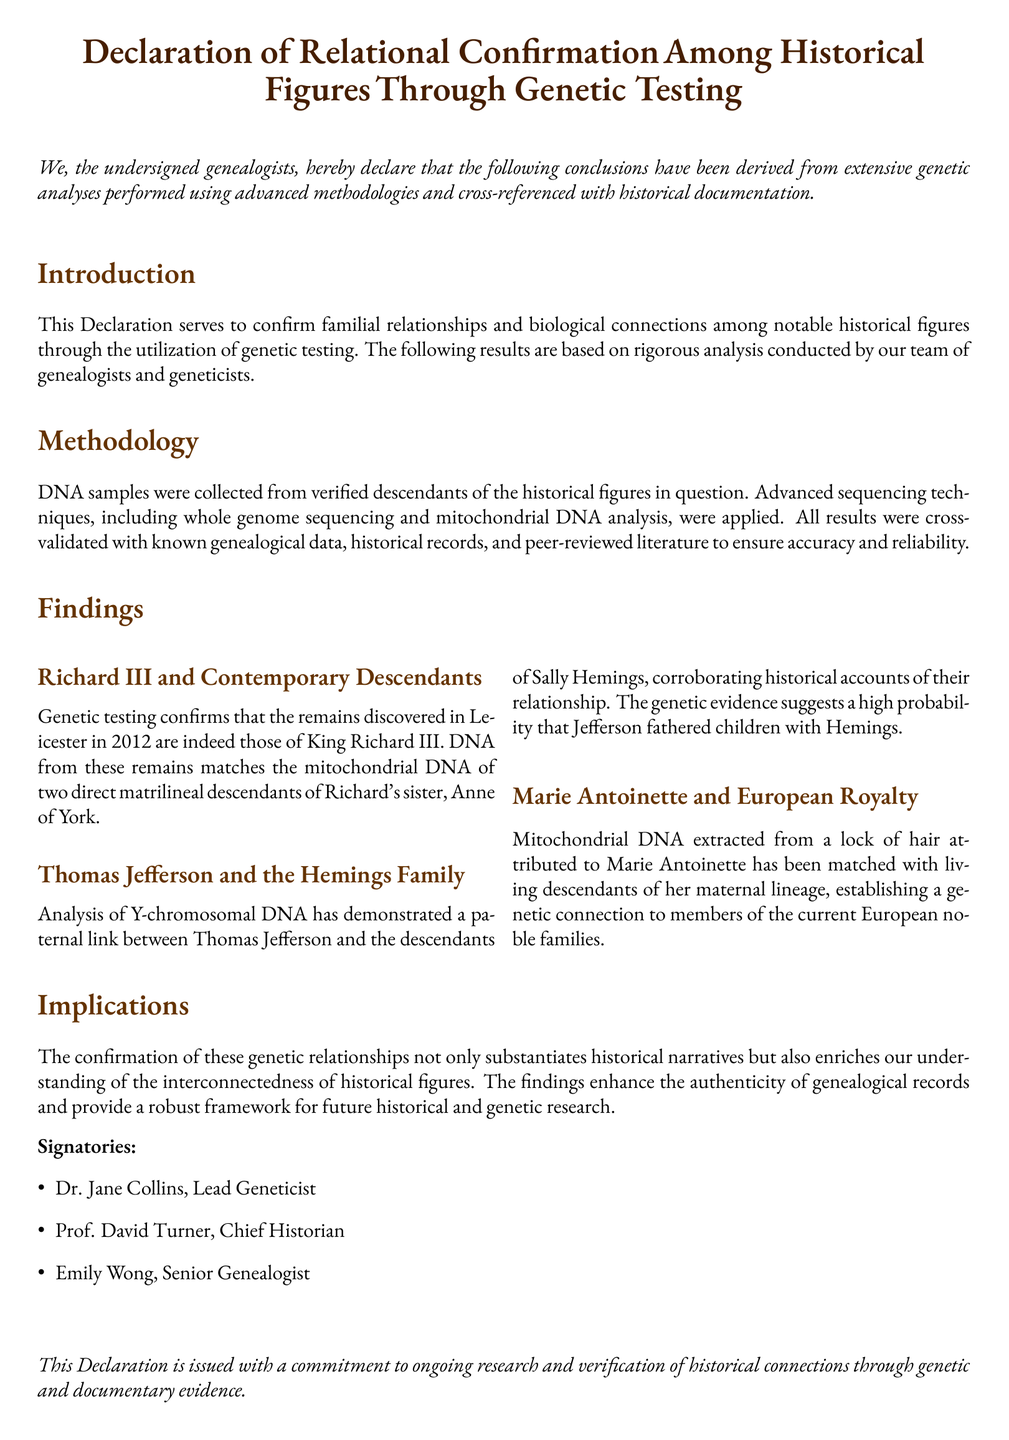What is the title of the document? The title of the document is presented at the top, indicating the purpose of the declaration regarding historical figures and genetic testing.
Answer: Declaration of Relational Confirmation Among Historical Figures Through Genetic Testing Who is the Lead Geneticist? The Lead Geneticist is listed among the signatories of the declaration, showcasing their role in the research.
Answer: Dr. Jane Collins What year were the remains of King Richard III discovered? The document mentions a specific year regarding the discovery of Richard III's remains.
Answer: 2012 Which historical figure is associated with the Hemings family? This figure is explicitly linked to the Hemings family in the findings section of the document.
Answer: Thomas Jefferson What type of DNA analysis was used for confirming the relationship between Thomas Jefferson and the Hemings Family? The analysis type specifies the focus of the genetic linkage investigation outlined in the findings.
Answer: Y-chromosomal DNA What methodology was employed for the analysis? The document outlines specific techniques used in the genetic testing process and validation of results.
Answer: Whole genome sequencing and mitochondrial DNA analysis How many signatories are listed in the document? The document provides a list of signatories at the end, indicating the number of individuals involved in the declaration.
Answer: 3 What is the primary purpose of this declaration? The main objective of the declaration is summarized in the introductory statement addressing what the findings confirm.
Answer: To confirm familial relationships and biological connections among historical figures 